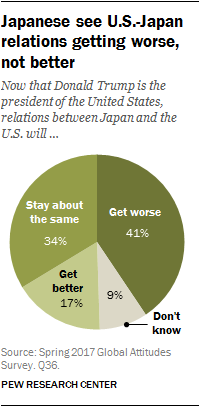Identify some key points in this picture. The percentage value of the smallest segment is 9. The largest pie among the three has a percentage value of 0.34. 